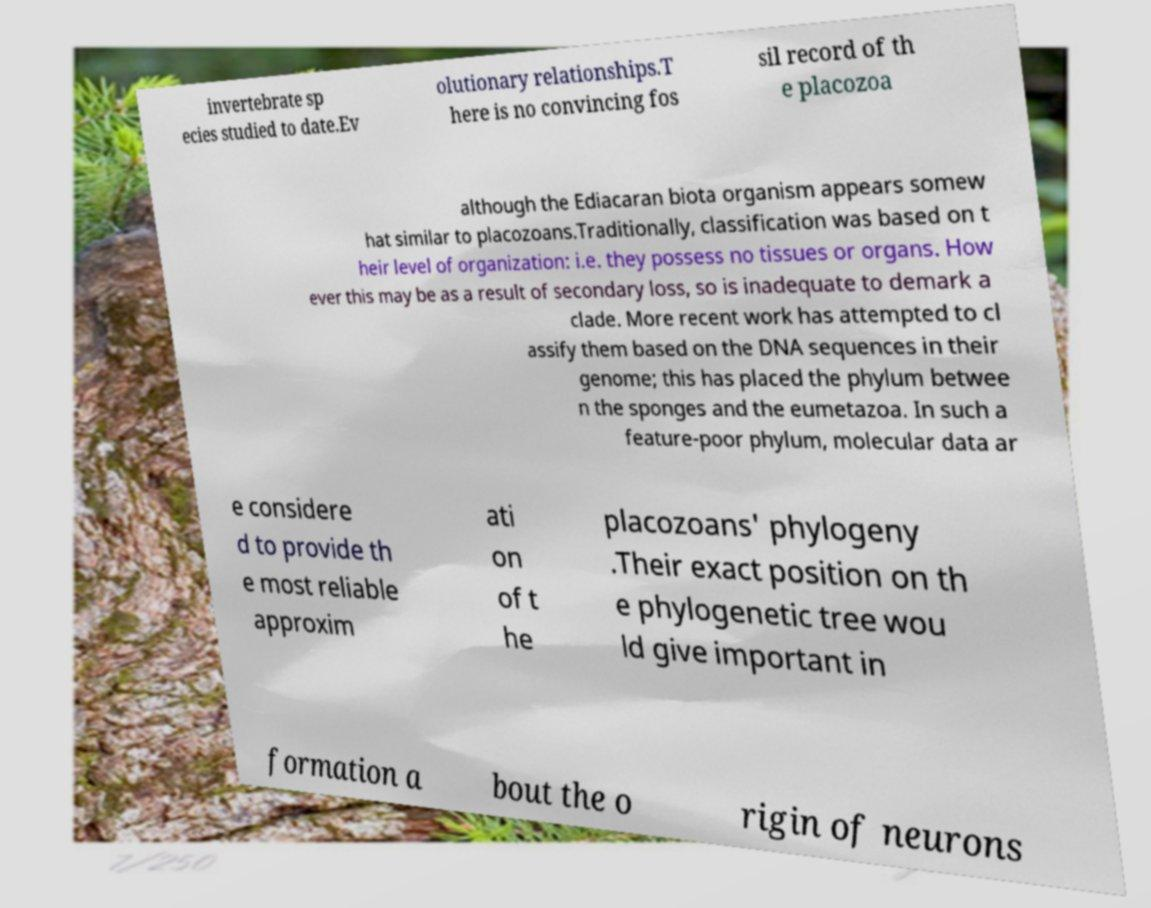Please identify and transcribe the text found in this image. invertebrate sp ecies studied to date.Ev olutionary relationships.T here is no convincing fos sil record of th e placozoa although the Ediacaran biota organism appears somew hat similar to placozoans.Traditionally, classification was based on t heir level of organization: i.e. they possess no tissues or organs. How ever this may be as a result of secondary loss, so is inadequate to demark a clade. More recent work has attempted to cl assify them based on the DNA sequences in their genome; this has placed the phylum betwee n the sponges and the eumetazoa. In such a feature-poor phylum, molecular data ar e considere d to provide th e most reliable approxim ati on of t he placozoans' phylogeny .Their exact position on th e phylogenetic tree wou ld give important in formation a bout the o rigin of neurons 